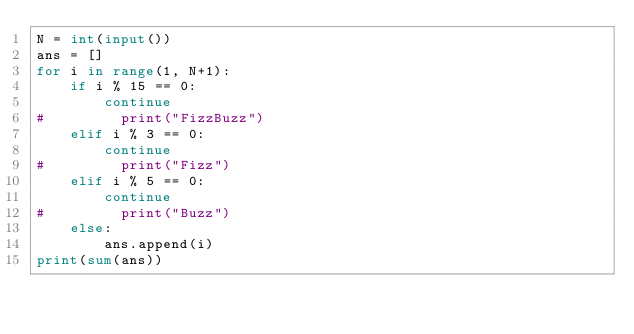<code> <loc_0><loc_0><loc_500><loc_500><_Python_>N = int(input())
ans = []
for i in range(1, N+1):
    if i % 15 == 0:
        continue
#         print("FizzBuzz")
    elif i % 3 == 0:
        continue
#         print("Fizz")
    elif i % 5 == 0:
        continue
#         print("Buzz")
    else:
        ans.append(i)
print(sum(ans))</code> 